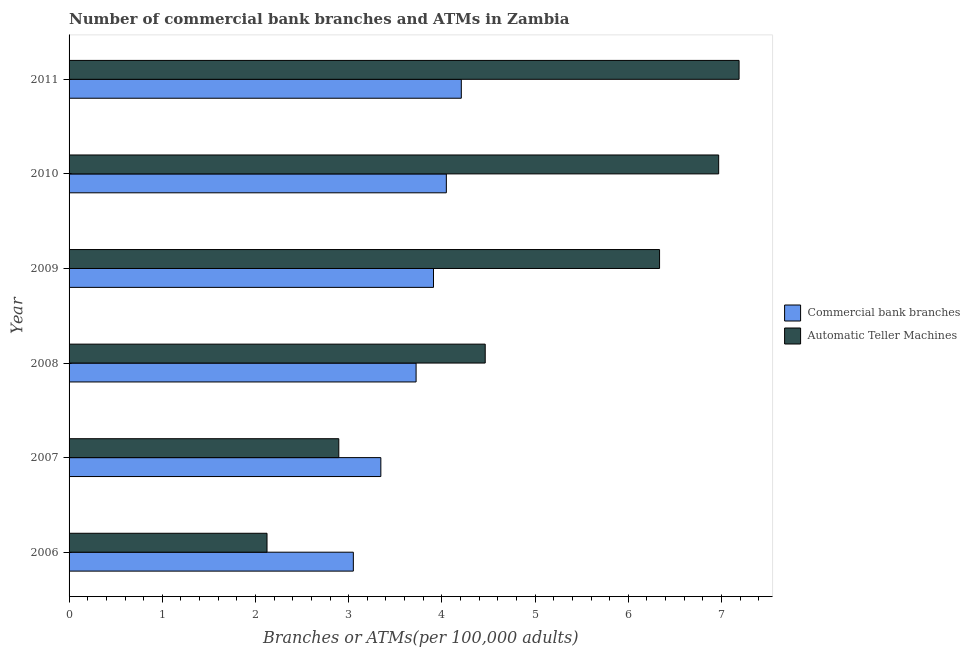How many different coloured bars are there?
Offer a terse response. 2. How many groups of bars are there?
Provide a succinct answer. 6. Are the number of bars on each tick of the Y-axis equal?
Provide a short and direct response. Yes. In how many cases, is the number of bars for a given year not equal to the number of legend labels?
Provide a short and direct response. 0. What is the number of commercal bank branches in 2011?
Your answer should be very brief. 4.21. Across all years, what is the maximum number of commercal bank branches?
Provide a succinct answer. 4.21. Across all years, what is the minimum number of atms?
Provide a short and direct response. 2.12. In which year was the number of commercal bank branches maximum?
Give a very brief answer. 2011. In which year was the number of atms minimum?
Your answer should be very brief. 2006. What is the total number of atms in the graph?
Offer a terse response. 29.97. What is the difference between the number of commercal bank branches in 2010 and that in 2011?
Keep it short and to the point. -0.16. What is the difference between the number of commercal bank branches in 2006 and the number of atms in 2011?
Offer a very short reply. -4.14. What is the average number of atms per year?
Give a very brief answer. 5. In the year 2010, what is the difference between the number of atms and number of commercal bank branches?
Your response must be concise. 2.92. In how many years, is the number of atms greater than 3 ?
Your response must be concise. 4. What is the ratio of the number of atms in 2007 to that in 2011?
Make the answer very short. 0.4. Is the number of commercal bank branches in 2009 less than that in 2011?
Make the answer very short. Yes. What is the difference between the highest and the second highest number of atms?
Provide a short and direct response. 0.22. What is the difference between the highest and the lowest number of atms?
Keep it short and to the point. 5.06. What does the 1st bar from the top in 2006 represents?
Offer a very short reply. Automatic Teller Machines. What does the 1st bar from the bottom in 2011 represents?
Your answer should be very brief. Commercial bank branches. How many years are there in the graph?
Your answer should be compact. 6. What is the difference between two consecutive major ticks on the X-axis?
Provide a short and direct response. 1. Does the graph contain grids?
Offer a very short reply. No. Where does the legend appear in the graph?
Offer a very short reply. Center right. How many legend labels are there?
Your response must be concise. 2. What is the title of the graph?
Your response must be concise. Number of commercial bank branches and ATMs in Zambia. Does "Non-residents" appear as one of the legend labels in the graph?
Give a very brief answer. No. What is the label or title of the X-axis?
Your answer should be compact. Branches or ATMs(per 100,0 adults). What is the label or title of the Y-axis?
Ensure brevity in your answer.  Year. What is the Branches or ATMs(per 100,000 adults) in Commercial bank branches in 2006?
Give a very brief answer. 3.05. What is the Branches or ATMs(per 100,000 adults) of Automatic Teller Machines in 2006?
Your answer should be very brief. 2.12. What is the Branches or ATMs(per 100,000 adults) of Commercial bank branches in 2007?
Provide a succinct answer. 3.34. What is the Branches or ATMs(per 100,000 adults) of Automatic Teller Machines in 2007?
Provide a short and direct response. 2.89. What is the Branches or ATMs(per 100,000 adults) in Commercial bank branches in 2008?
Provide a short and direct response. 3.72. What is the Branches or ATMs(per 100,000 adults) of Automatic Teller Machines in 2008?
Provide a short and direct response. 4.46. What is the Branches or ATMs(per 100,000 adults) of Commercial bank branches in 2009?
Ensure brevity in your answer.  3.91. What is the Branches or ATMs(per 100,000 adults) of Automatic Teller Machines in 2009?
Make the answer very short. 6.33. What is the Branches or ATMs(per 100,000 adults) of Commercial bank branches in 2010?
Give a very brief answer. 4.05. What is the Branches or ATMs(per 100,000 adults) of Automatic Teller Machines in 2010?
Offer a terse response. 6.97. What is the Branches or ATMs(per 100,000 adults) in Commercial bank branches in 2011?
Keep it short and to the point. 4.21. What is the Branches or ATMs(per 100,000 adults) in Automatic Teller Machines in 2011?
Your answer should be very brief. 7.19. Across all years, what is the maximum Branches or ATMs(per 100,000 adults) in Commercial bank branches?
Your answer should be compact. 4.21. Across all years, what is the maximum Branches or ATMs(per 100,000 adults) in Automatic Teller Machines?
Make the answer very short. 7.19. Across all years, what is the minimum Branches or ATMs(per 100,000 adults) in Commercial bank branches?
Offer a terse response. 3.05. Across all years, what is the minimum Branches or ATMs(per 100,000 adults) in Automatic Teller Machines?
Provide a succinct answer. 2.12. What is the total Branches or ATMs(per 100,000 adults) in Commercial bank branches in the graph?
Your response must be concise. 22.28. What is the total Branches or ATMs(per 100,000 adults) of Automatic Teller Machines in the graph?
Keep it short and to the point. 29.97. What is the difference between the Branches or ATMs(per 100,000 adults) of Commercial bank branches in 2006 and that in 2007?
Give a very brief answer. -0.3. What is the difference between the Branches or ATMs(per 100,000 adults) in Automatic Teller Machines in 2006 and that in 2007?
Provide a short and direct response. -0.77. What is the difference between the Branches or ATMs(per 100,000 adults) of Commercial bank branches in 2006 and that in 2008?
Provide a short and direct response. -0.67. What is the difference between the Branches or ATMs(per 100,000 adults) in Automatic Teller Machines in 2006 and that in 2008?
Offer a terse response. -2.34. What is the difference between the Branches or ATMs(per 100,000 adults) in Commercial bank branches in 2006 and that in 2009?
Your answer should be compact. -0.86. What is the difference between the Branches or ATMs(per 100,000 adults) in Automatic Teller Machines in 2006 and that in 2009?
Offer a terse response. -4.21. What is the difference between the Branches or ATMs(per 100,000 adults) of Commercial bank branches in 2006 and that in 2010?
Offer a very short reply. -1. What is the difference between the Branches or ATMs(per 100,000 adults) in Automatic Teller Machines in 2006 and that in 2010?
Provide a short and direct response. -4.85. What is the difference between the Branches or ATMs(per 100,000 adults) in Commercial bank branches in 2006 and that in 2011?
Provide a succinct answer. -1.16. What is the difference between the Branches or ATMs(per 100,000 adults) in Automatic Teller Machines in 2006 and that in 2011?
Offer a very short reply. -5.06. What is the difference between the Branches or ATMs(per 100,000 adults) of Commercial bank branches in 2007 and that in 2008?
Provide a succinct answer. -0.38. What is the difference between the Branches or ATMs(per 100,000 adults) in Automatic Teller Machines in 2007 and that in 2008?
Provide a succinct answer. -1.57. What is the difference between the Branches or ATMs(per 100,000 adults) of Commercial bank branches in 2007 and that in 2009?
Make the answer very short. -0.56. What is the difference between the Branches or ATMs(per 100,000 adults) in Automatic Teller Machines in 2007 and that in 2009?
Provide a short and direct response. -3.44. What is the difference between the Branches or ATMs(per 100,000 adults) of Commercial bank branches in 2007 and that in 2010?
Provide a short and direct response. -0.7. What is the difference between the Branches or ATMs(per 100,000 adults) of Automatic Teller Machines in 2007 and that in 2010?
Keep it short and to the point. -4.08. What is the difference between the Branches or ATMs(per 100,000 adults) in Commercial bank branches in 2007 and that in 2011?
Give a very brief answer. -0.86. What is the difference between the Branches or ATMs(per 100,000 adults) in Automatic Teller Machines in 2007 and that in 2011?
Give a very brief answer. -4.29. What is the difference between the Branches or ATMs(per 100,000 adults) of Commercial bank branches in 2008 and that in 2009?
Your response must be concise. -0.19. What is the difference between the Branches or ATMs(per 100,000 adults) of Automatic Teller Machines in 2008 and that in 2009?
Your answer should be compact. -1.87. What is the difference between the Branches or ATMs(per 100,000 adults) of Commercial bank branches in 2008 and that in 2010?
Ensure brevity in your answer.  -0.32. What is the difference between the Branches or ATMs(per 100,000 adults) of Automatic Teller Machines in 2008 and that in 2010?
Offer a very short reply. -2.5. What is the difference between the Branches or ATMs(per 100,000 adults) in Commercial bank branches in 2008 and that in 2011?
Your answer should be very brief. -0.48. What is the difference between the Branches or ATMs(per 100,000 adults) of Automatic Teller Machines in 2008 and that in 2011?
Make the answer very short. -2.72. What is the difference between the Branches or ATMs(per 100,000 adults) of Commercial bank branches in 2009 and that in 2010?
Give a very brief answer. -0.14. What is the difference between the Branches or ATMs(per 100,000 adults) in Automatic Teller Machines in 2009 and that in 2010?
Make the answer very short. -0.63. What is the difference between the Branches or ATMs(per 100,000 adults) of Commercial bank branches in 2009 and that in 2011?
Make the answer very short. -0.3. What is the difference between the Branches or ATMs(per 100,000 adults) in Automatic Teller Machines in 2009 and that in 2011?
Offer a very short reply. -0.85. What is the difference between the Branches or ATMs(per 100,000 adults) of Commercial bank branches in 2010 and that in 2011?
Your response must be concise. -0.16. What is the difference between the Branches or ATMs(per 100,000 adults) in Automatic Teller Machines in 2010 and that in 2011?
Your response must be concise. -0.22. What is the difference between the Branches or ATMs(per 100,000 adults) in Commercial bank branches in 2006 and the Branches or ATMs(per 100,000 adults) in Automatic Teller Machines in 2007?
Keep it short and to the point. 0.16. What is the difference between the Branches or ATMs(per 100,000 adults) of Commercial bank branches in 2006 and the Branches or ATMs(per 100,000 adults) of Automatic Teller Machines in 2008?
Offer a terse response. -1.41. What is the difference between the Branches or ATMs(per 100,000 adults) of Commercial bank branches in 2006 and the Branches or ATMs(per 100,000 adults) of Automatic Teller Machines in 2009?
Offer a terse response. -3.29. What is the difference between the Branches or ATMs(per 100,000 adults) in Commercial bank branches in 2006 and the Branches or ATMs(per 100,000 adults) in Automatic Teller Machines in 2010?
Your answer should be compact. -3.92. What is the difference between the Branches or ATMs(per 100,000 adults) in Commercial bank branches in 2006 and the Branches or ATMs(per 100,000 adults) in Automatic Teller Machines in 2011?
Provide a short and direct response. -4.14. What is the difference between the Branches or ATMs(per 100,000 adults) of Commercial bank branches in 2007 and the Branches or ATMs(per 100,000 adults) of Automatic Teller Machines in 2008?
Make the answer very short. -1.12. What is the difference between the Branches or ATMs(per 100,000 adults) in Commercial bank branches in 2007 and the Branches or ATMs(per 100,000 adults) in Automatic Teller Machines in 2009?
Provide a short and direct response. -2.99. What is the difference between the Branches or ATMs(per 100,000 adults) in Commercial bank branches in 2007 and the Branches or ATMs(per 100,000 adults) in Automatic Teller Machines in 2010?
Offer a terse response. -3.62. What is the difference between the Branches or ATMs(per 100,000 adults) of Commercial bank branches in 2007 and the Branches or ATMs(per 100,000 adults) of Automatic Teller Machines in 2011?
Ensure brevity in your answer.  -3.84. What is the difference between the Branches or ATMs(per 100,000 adults) of Commercial bank branches in 2008 and the Branches or ATMs(per 100,000 adults) of Automatic Teller Machines in 2009?
Your response must be concise. -2.61. What is the difference between the Branches or ATMs(per 100,000 adults) of Commercial bank branches in 2008 and the Branches or ATMs(per 100,000 adults) of Automatic Teller Machines in 2010?
Your answer should be compact. -3.25. What is the difference between the Branches or ATMs(per 100,000 adults) in Commercial bank branches in 2008 and the Branches or ATMs(per 100,000 adults) in Automatic Teller Machines in 2011?
Provide a succinct answer. -3.47. What is the difference between the Branches or ATMs(per 100,000 adults) of Commercial bank branches in 2009 and the Branches or ATMs(per 100,000 adults) of Automatic Teller Machines in 2010?
Your response must be concise. -3.06. What is the difference between the Branches or ATMs(per 100,000 adults) in Commercial bank branches in 2009 and the Branches or ATMs(per 100,000 adults) in Automatic Teller Machines in 2011?
Your answer should be compact. -3.28. What is the difference between the Branches or ATMs(per 100,000 adults) of Commercial bank branches in 2010 and the Branches or ATMs(per 100,000 adults) of Automatic Teller Machines in 2011?
Make the answer very short. -3.14. What is the average Branches or ATMs(per 100,000 adults) in Commercial bank branches per year?
Offer a very short reply. 3.71. What is the average Branches or ATMs(per 100,000 adults) of Automatic Teller Machines per year?
Your response must be concise. 5. In the year 2006, what is the difference between the Branches or ATMs(per 100,000 adults) in Commercial bank branches and Branches or ATMs(per 100,000 adults) in Automatic Teller Machines?
Keep it short and to the point. 0.93. In the year 2007, what is the difference between the Branches or ATMs(per 100,000 adults) in Commercial bank branches and Branches or ATMs(per 100,000 adults) in Automatic Teller Machines?
Offer a very short reply. 0.45. In the year 2008, what is the difference between the Branches or ATMs(per 100,000 adults) in Commercial bank branches and Branches or ATMs(per 100,000 adults) in Automatic Teller Machines?
Provide a short and direct response. -0.74. In the year 2009, what is the difference between the Branches or ATMs(per 100,000 adults) of Commercial bank branches and Branches or ATMs(per 100,000 adults) of Automatic Teller Machines?
Provide a succinct answer. -2.43. In the year 2010, what is the difference between the Branches or ATMs(per 100,000 adults) of Commercial bank branches and Branches or ATMs(per 100,000 adults) of Automatic Teller Machines?
Ensure brevity in your answer.  -2.92. In the year 2011, what is the difference between the Branches or ATMs(per 100,000 adults) of Commercial bank branches and Branches or ATMs(per 100,000 adults) of Automatic Teller Machines?
Ensure brevity in your answer.  -2.98. What is the ratio of the Branches or ATMs(per 100,000 adults) in Commercial bank branches in 2006 to that in 2007?
Provide a short and direct response. 0.91. What is the ratio of the Branches or ATMs(per 100,000 adults) of Automatic Teller Machines in 2006 to that in 2007?
Make the answer very short. 0.73. What is the ratio of the Branches or ATMs(per 100,000 adults) of Commercial bank branches in 2006 to that in 2008?
Keep it short and to the point. 0.82. What is the ratio of the Branches or ATMs(per 100,000 adults) of Automatic Teller Machines in 2006 to that in 2008?
Offer a terse response. 0.48. What is the ratio of the Branches or ATMs(per 100,000 adults) in Commercial bank branches in 2006 to that in 2009?
Make the answer very short. 0.78. What is the ratio of the Branches or ATMs(per 100,000 adults) of Automatic Teller Machines in 2006 to that in 2009?
Ensure brevity in your answer.  0.34. What is the ratio of the Branches or ATMs(per 100,000 adults) in Commercial bank branches in 2006 to that in 2010?
Make the answer very short. 0.75. What is the ratio of the Branches or ATMs(per 100,000 adults) of Automatic Teller Machines in 2006 to that in 2010?
Ensure brevity in your answer.  0.3. What is the ratio of the Branches or ATMs(per 100,000 adults) of Commercial bank branches in 2006 to that in 2011?
Offer a very short reply. 0.72. What is the ratio of the Branches or ATMs(per 100,000 adults) of Automatic Teller Machines in 2006 to that in 2011?
Your response must be concise. 0.3. What is the ratio of the Branches or ATMs(per 100,000 adults) of Commercial bank branches in 2007 to that in 2008?
Make the answer very short. 0.9. What is the ratio of the Branches or ATMs(per 100,000 adults) of Automatic Teller Machines in 2007 to that in 2008?
Offer a very short reply. 0.65. What is the ratio of the Branches or ATMs(per 100,000 adults) in Commercial bank branches in 2007 to that in 2009?
Make the answer very short. 0.86. What is the ratio of the Branches or ATMs(per 100,000 adults) in Automatic Teller Machines in 2007 to that in 2009?
Give a very brief answer. 0.46. What is the ratio of the Branches or ATMs(per 100,000 adults) in Commercial bank branches in 2007 to that in 2010?
Keep it short and to the point. 0.83. What is the ratio of the Branches or ATMs(per 100,000 adults) in Automatic Teller Machines in 2007 to that in 2010?
Offer a very short reply. 0.42. What is the ratio of the Branches or ATMs(per 100,000 adults) of Commercial bank branches in 2007 to that in 2011?
Your answer should be compact. 0.79. What is the ratio of the Branches or ATMs(per 100,000 adults) in Automatic Teller Machines in 2007 to that in 2011?
Your answer should be very brief. 0.4. What is the ratio of the Branches or ATMs(per 100,000 adults) of Commercial bank branches in 2008 to that in 2009?
Provide a succinct answer. 0.95. What is the ratio of the Branches or ATMs(per 100,000 adults) of Automatic Teller Machines in 2008 to that in 2009?
Provide a short and direct response. 0.7. What is the ratio of the Branches or ATMs(per 100,000 adults) of Commercial bank branches in 2008 to that in 2010?
Provide a succinct answer. 0.92. What is the ratio of the Branches or ATMs(per 100,000 adults) of Automatic Teller Machines in 2008 to that in 2010?
Ensure brevity in your answer.  0.64. What is the ratio of the Branches or ATMs(per 100,000 adults) in Commercial bank branches in 2008 to that in 2011?
Your answer should be compact. 0.88. What is the ratio of the Branches or ATMs(per 100,000 adults) of Automatic Teller Machines in 2008 to that in 2011?
Ensure brevity in your answer.  0.62. What is the ratio of the Branches or ATMs(per 100,000 adults) in Commercial bank branches in 2009 to that in 2010?
Offer a very short reply. 0.97. What is the ratio of the Branches or ATMs(per 100,000 adults) in Automatic Teller Machines in 2009 to that in 2010?
Provide a succinct answer. 0.91. What is the ratio of the Branches or ATMs(per 100,000 adults) of Commercial bank branches in 2009 to that in 2011?
Provide a short and direct response. 0.93. What is the ratio of the Branches or ATMs(per 100,000 adults) in Automatic Teller Machines in 2009 to that in 2011?
Give a very brief answer. 0.88. What is the ratio of the Branches or ATMs(per 100,000 adults) in Commercial bank branches in 2010 to that in 2011?
Your response must be concise. 0.96. What is the ratio of the Branches or ATMs(per 100,000 adults) in Automatic Teller Machines in 2010 to that in 2011?
Give a very brief answer. 0.97. What is the difference between the highest and the second highest Branches or ATMs(per 100,000 adults) of Commercial bank branches?
Provide a short and direct response. 0.16. What is the difference between the highest and the second highest Branches or ATMs(per 100,000 adults) of Automatic Teller Machines?
Provide a succinct answer. 0.22. What is the difference between the highest and the lowest Branches or ATMs(per 100,000 adults) in Commercial bank branches?
Ensure brevity in your answer.  1.16. What is the difference between the highest and the lowest Branches or ATMs(per 100,000 adults) of Automatic Teller Machines?
Provide a succinct answer. 5.06. 